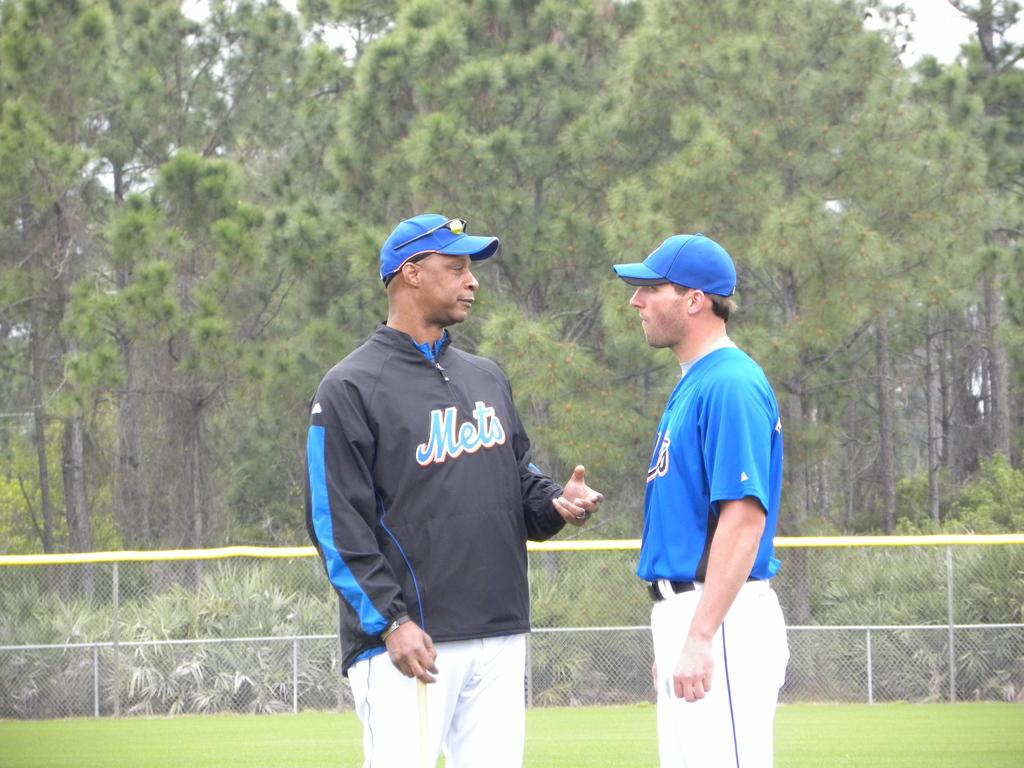<image>
Relay a brief, clear account of the picture shown. On the field, a Mets manager chats with a Mets player. 